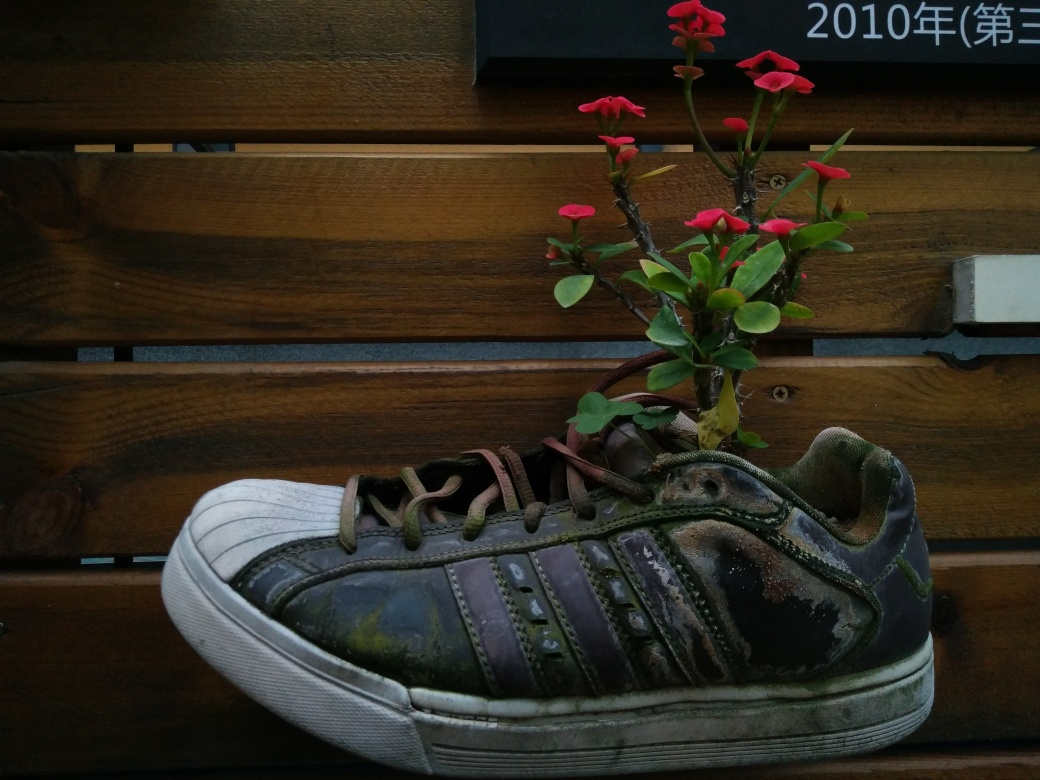What can be said about the color in the image?
A. Vibrant colors
B. Rich in color
C. Somewhat monotonous
D. Colorful palette The image primarily features shades of brown with a mostly worn-out appearance and muted tones, displaying a somewhat monotonous color scheme, accented by a small pop of vivid red from the flower which adds a touch of vibrancy to the otherwise subdued palette. 